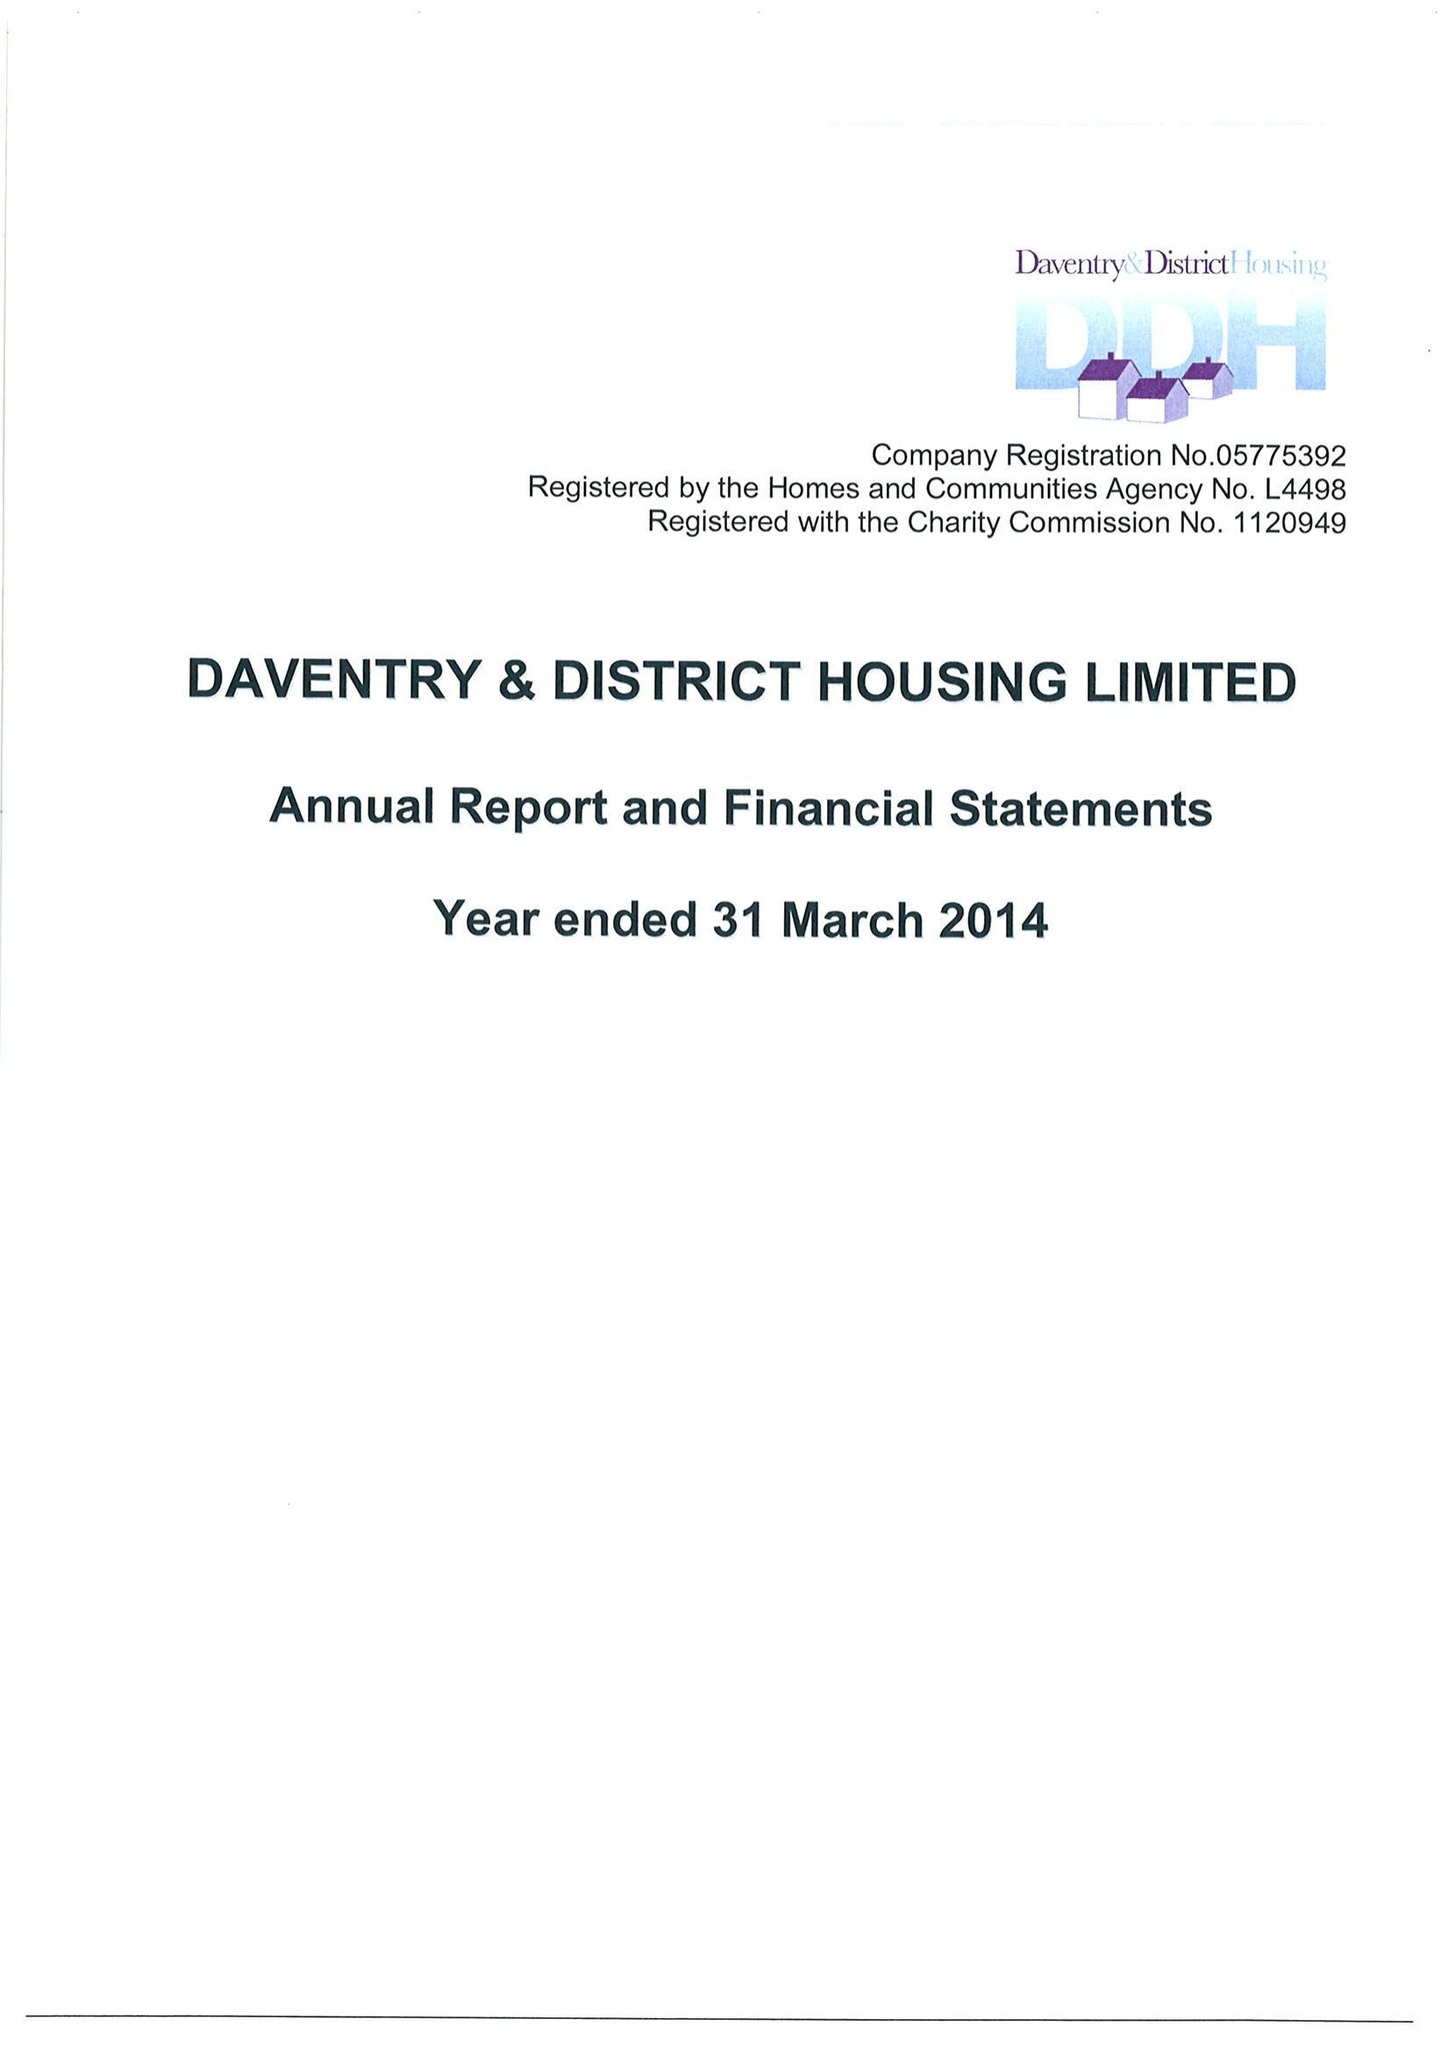What is the value for the address__street_line?
Answer the question using a single word or phrase. None 